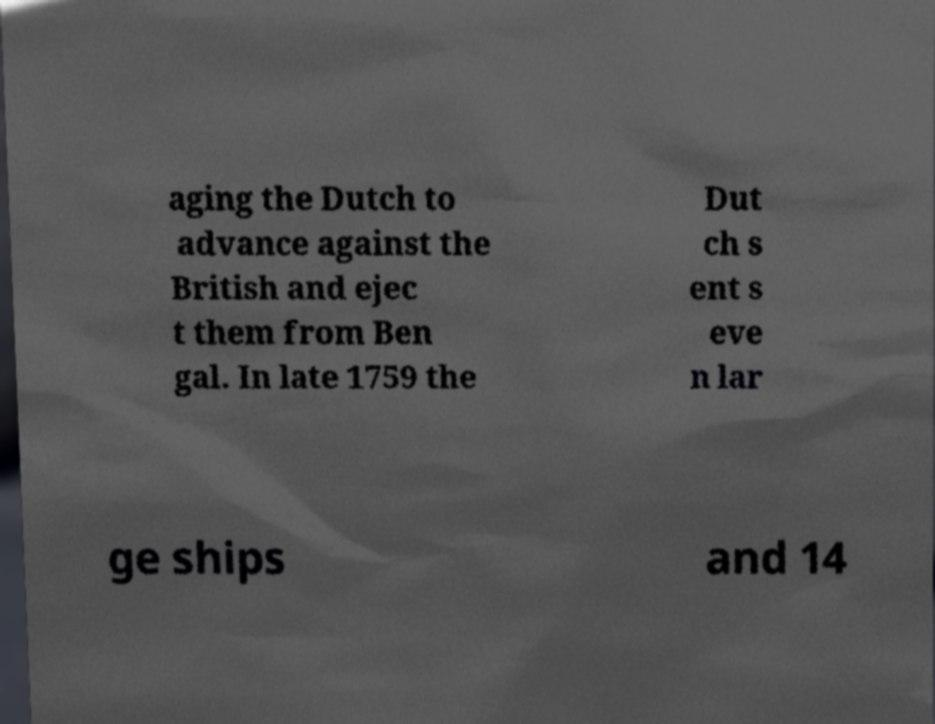Please identify and transcribe the text found in this image. aging the Dutch to advance against the British and ejec t them from Ben gal. In late 1759 the Dut ch s ent s eve n lar ge ships and 14 